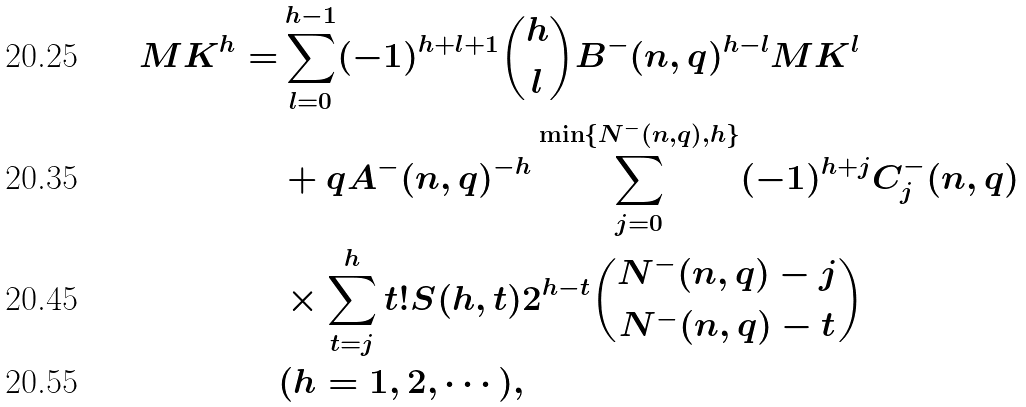Convert formula to latex. <formula><loc_0><loc_0><loc_500><loc_500>M K ^ { h } = & \sum _ { l = 0 } ^ { h - 1 } ( - 1 ) ^ { h + l + 1 } \binom { h } { l } B ^ { - } ( n , q ) ^ { h - l } M K ^ { l } \\ & + q A ^ { - } ( n , q ) ^ { - h } \sum _ { j = 0 } ^ { \min \{ N ^ { - } ( n , q ) , h \} } ( - 1 ) ^ { h + j } C _ { j } ^ { - } ( n , q ) \\ & \times \sum _ { t = j } ^ { h } t ! S ( h , t ) 2 ^ { h - t } \binom { N ^ { - } ( n , q ) - j } { N ^ { - } ( n , q ) - t } \\ & ( h = 1 , 2 , \cdots ) ,</formula> 